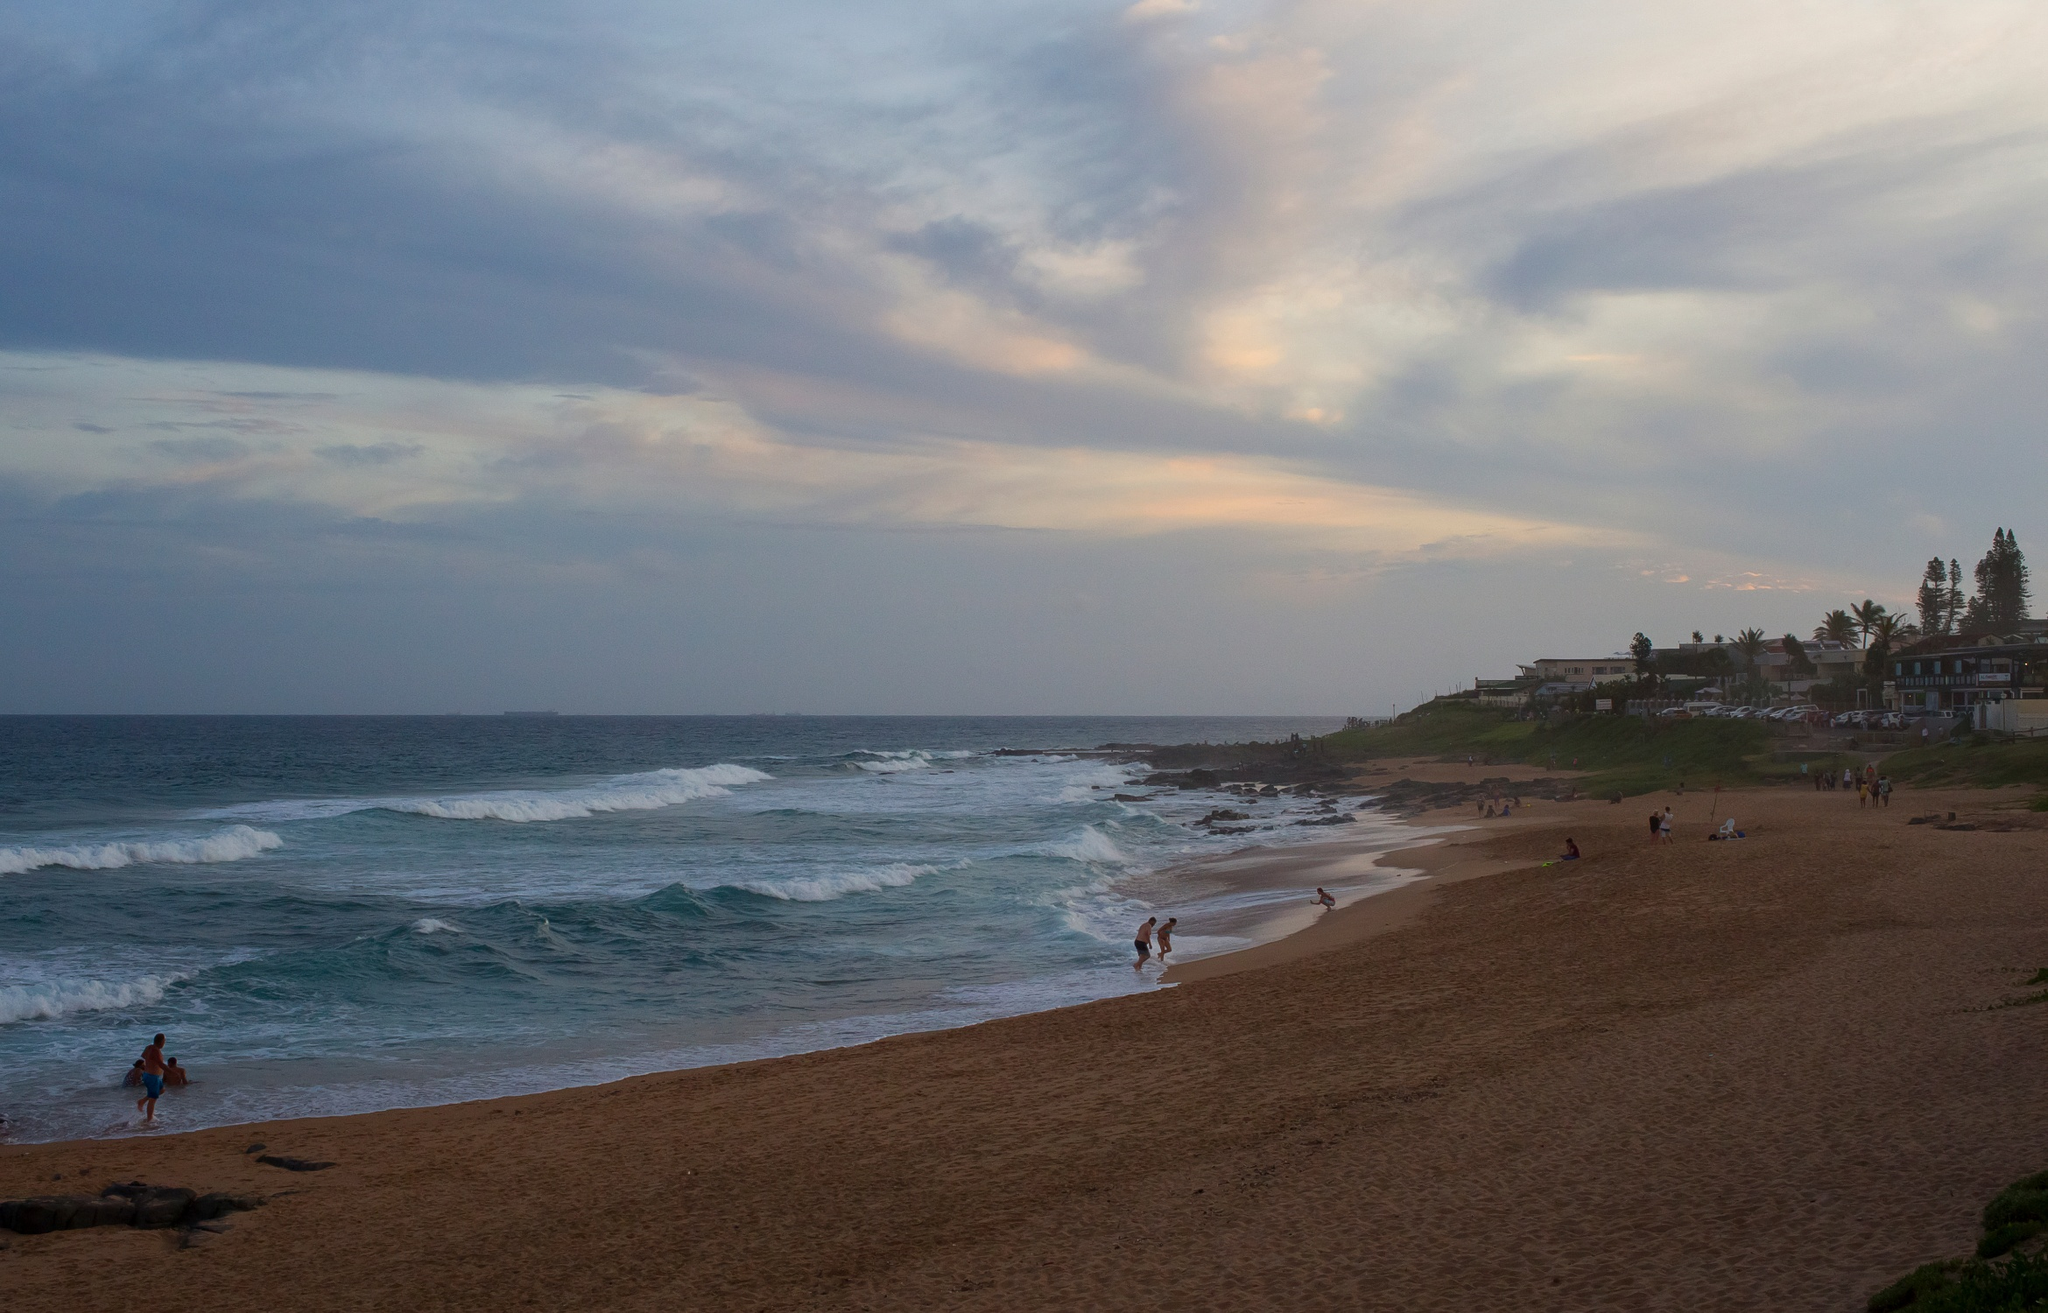Can you describe the mood of this image? The mood of this image is tranquil and serene. The soft colors of the sunset and the calmness of the ocean waves create a peaceful atmosphere. The few people scattered along the beach contribute to this sense of calm as they engage in leisurely activities, enjoying the natural beauty around them. What time of day do you think it is in the image? The image appears to be taken during sunset. The sky is filled with hues of blue and orange, indicating that the sun is close to the horizon, marking the end of the day. The lighting also suggests the soft and warm glow typically found during this time. Imagine this beach at midnight. How would the scene change? At midnight, the beach would transform dramatically. The sky would be a canvas of dark blue, dotted with countless stars, and perhaps a bright moon illuminating the scene with its silvery light. The ocean would appear darker, with the waves gently crashing against the shore, creating a soothing rhythm. The beach would be much quieter, likely devoid of people, and the only sounds would be the natural symphony of the waves and occasional night creatures. The houses on the cliff might have their lights on, casting soft glows and shadows around, creating an almost mystical aura. 